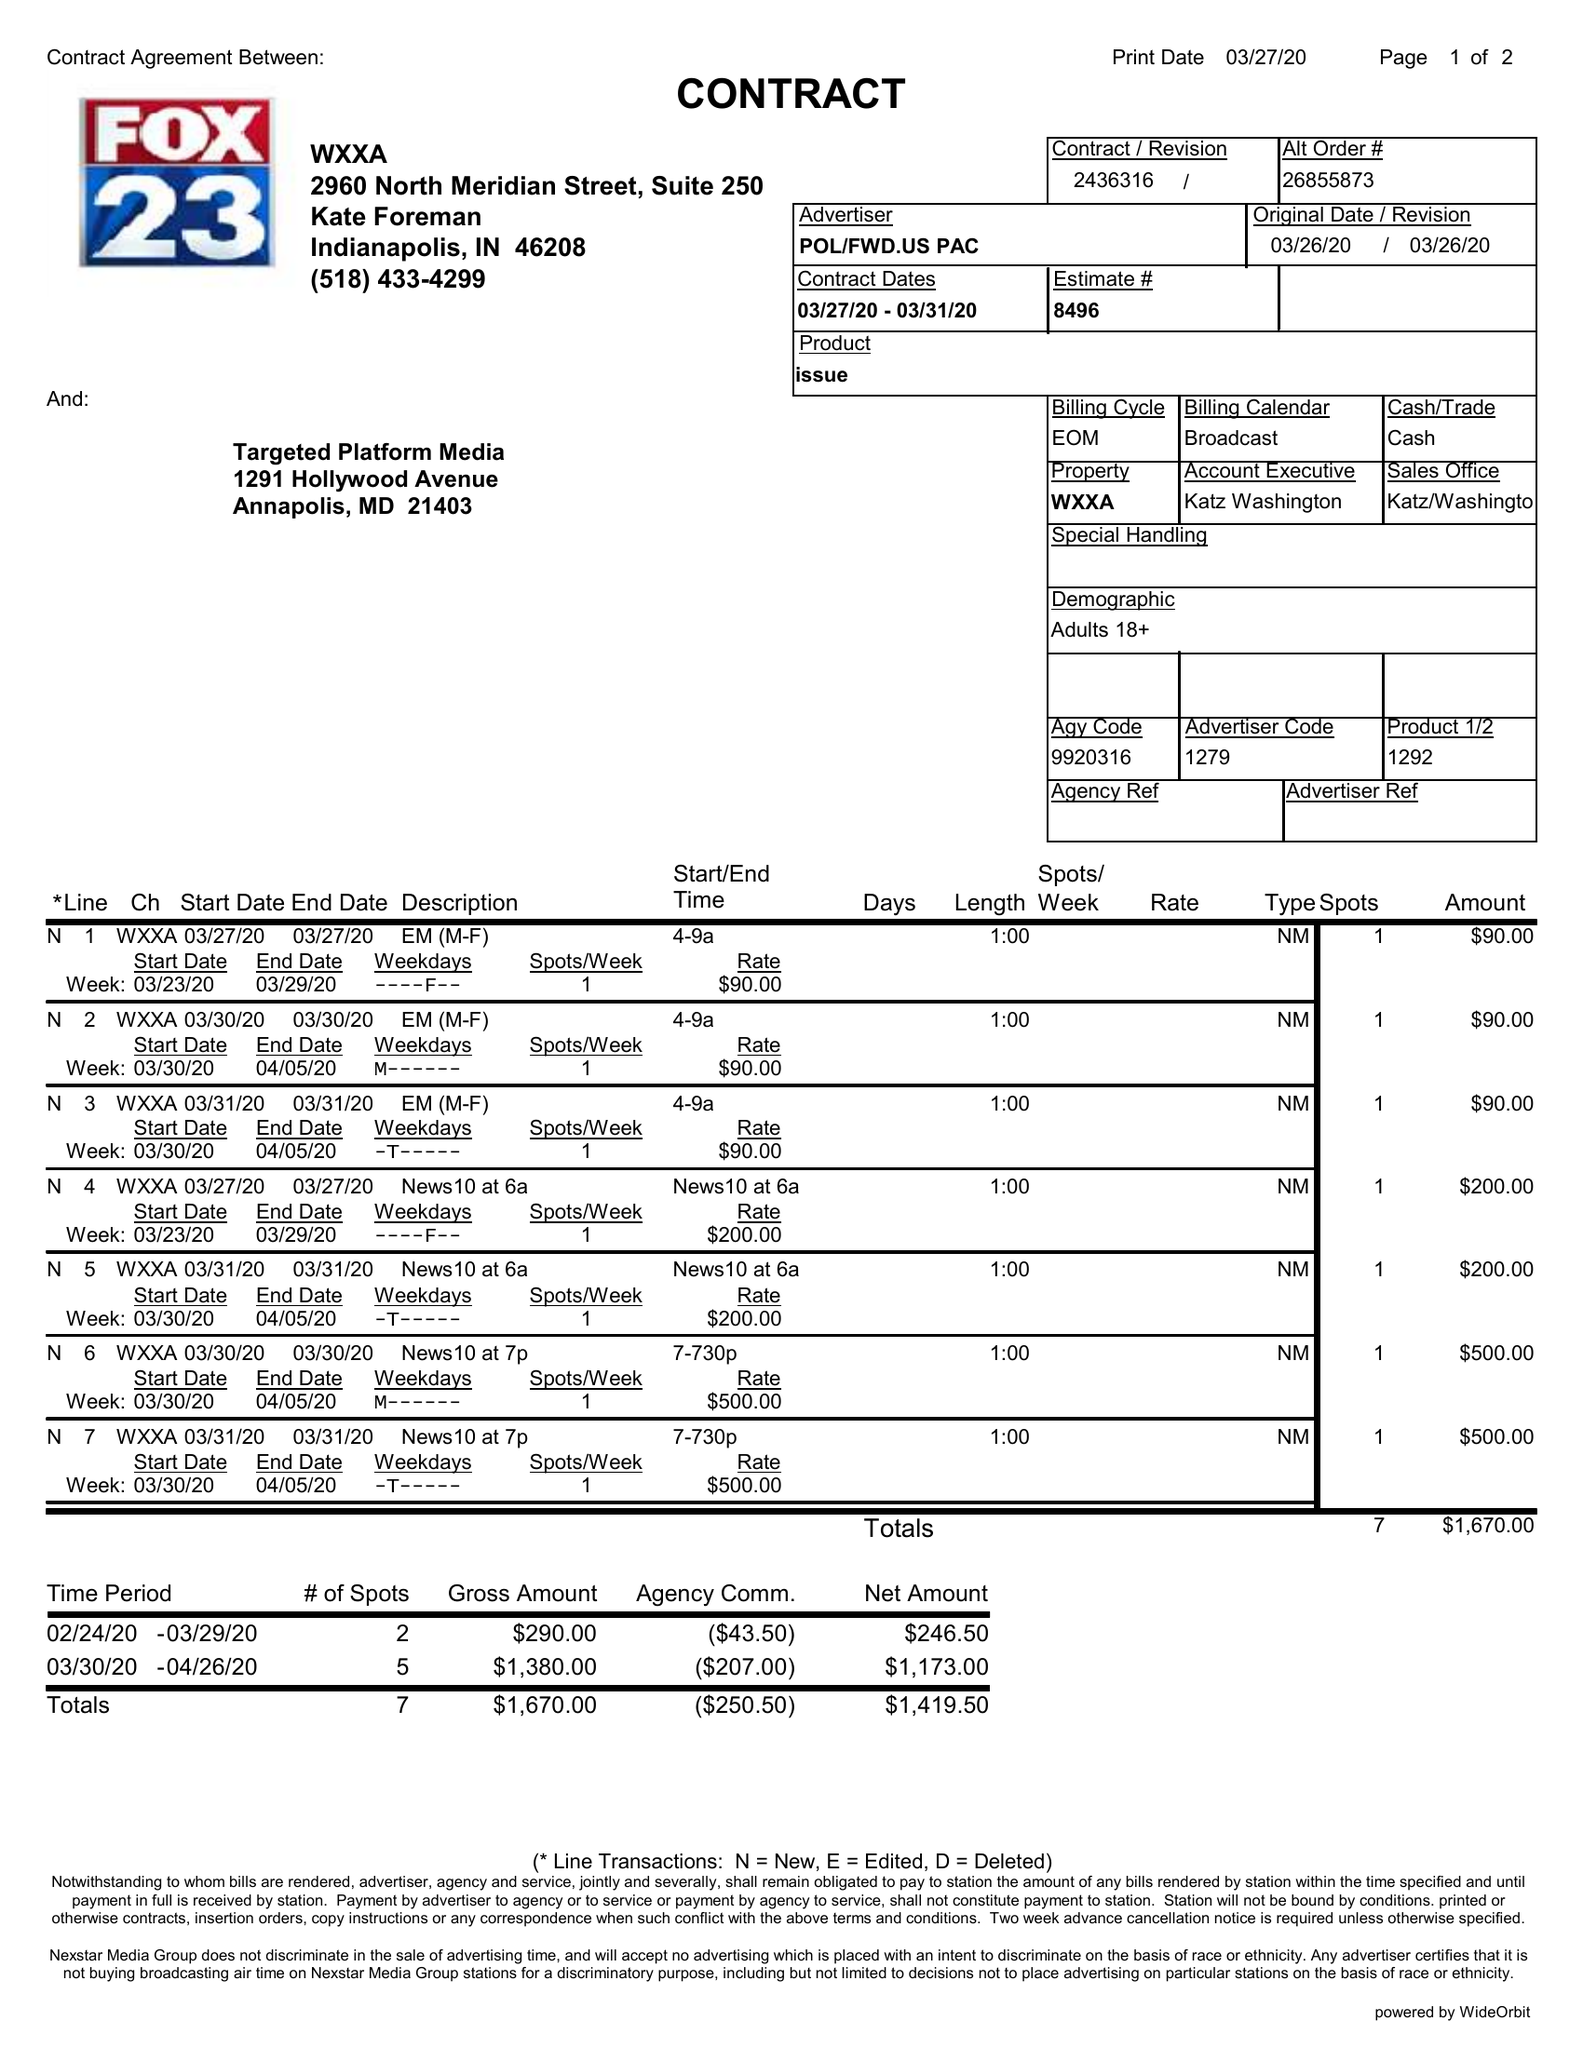What is the value for the gross_amount?
Answer the question using a single word or phrase. 1670.00 